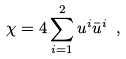Convert formula to latex. <formula><loc_0><loc_0><loc_500><loc_500>\chi = 4 \sum _ { i = 1 } ^ { 2 } u ^ { i } \bar { u } ^ { i } \ ,</formula> 